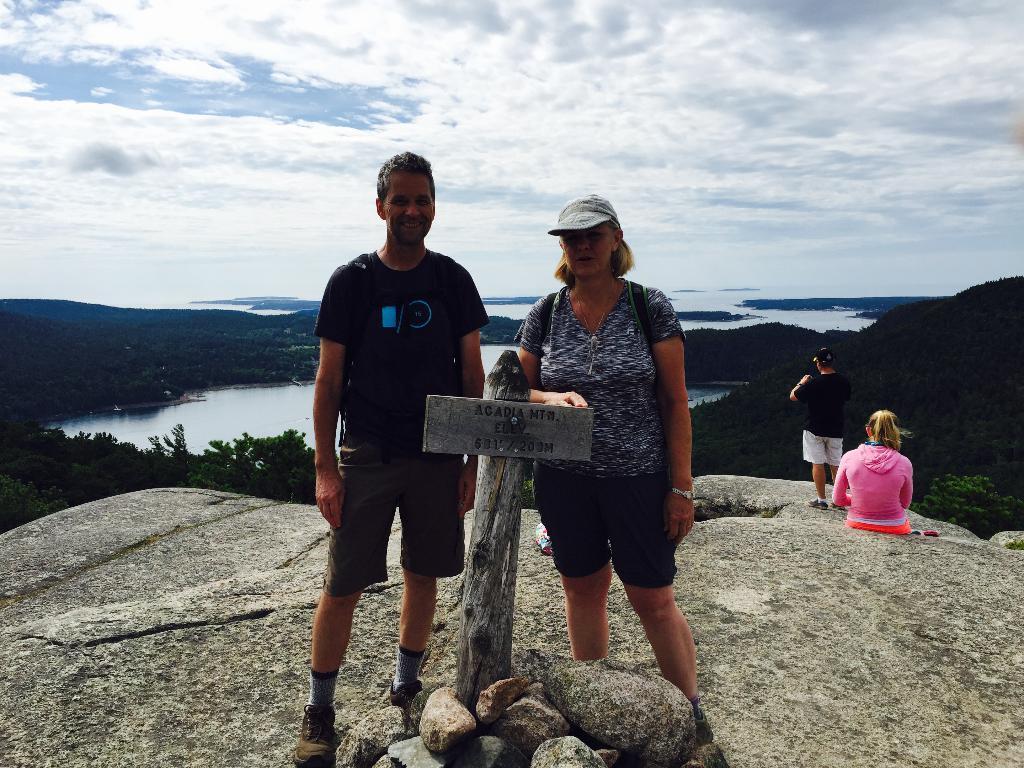What is attached to the pole in the image? There is a board attached to a pole in the image. What type of natural features can be seen in the image? There are rocks, hills, trees, and water visible in the image. How many people are present in the image? There are three people standing and one person sitting in the image, making a total of four people. What is visible in the sky in the image? The sky is visible in the image. What type of teeth can be seen in the image? There are no teeth visible in the image. What time is indicated by the alarm in the image? There is no alarm present in the image. 